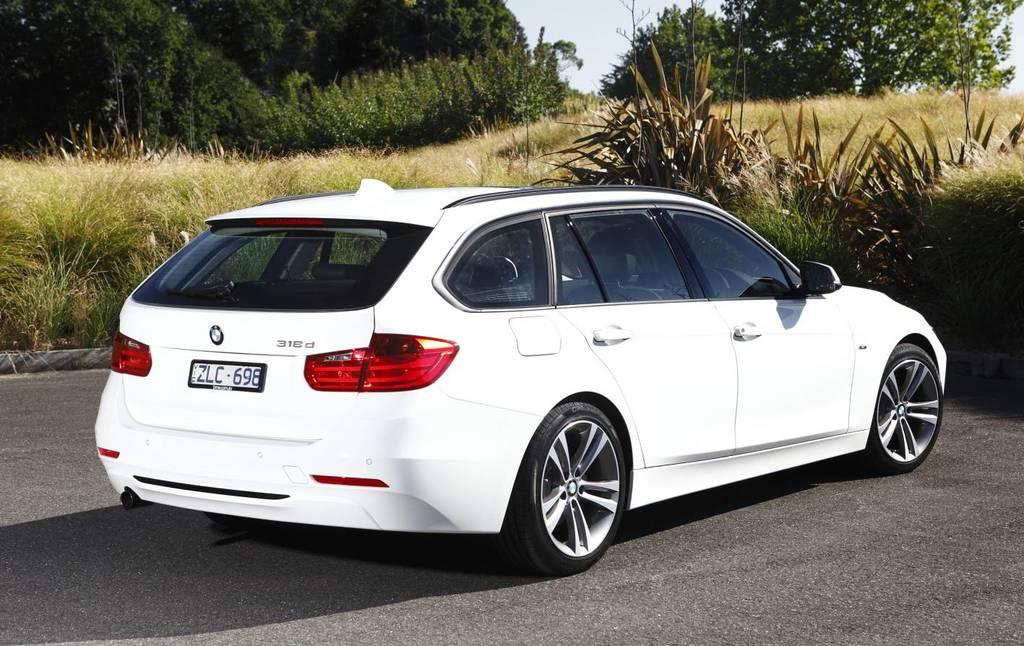<image>
Create a compact narrative representing the image presented. White car with a license plate that says ZLC698. 